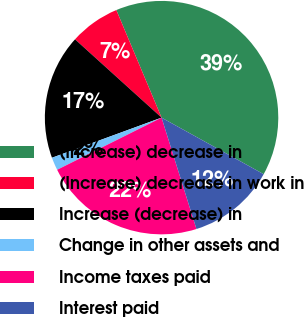<chart> <loc_0><loc_0><loc_500><loc_500><pie_chart><fcel>(Increase) decrease in<fcel>(Increase) decrease in work in<fcel>Increase (decrease) in<fcel>Change in other assets and<fcel>Income taxes paid<fcel>Interest paid<nl><fcel>39.39%<fcel>6.96%<fcel>17.29%<fcel>1.79%<fcel>22.46%<fcel>12.12%<nl></chart> 